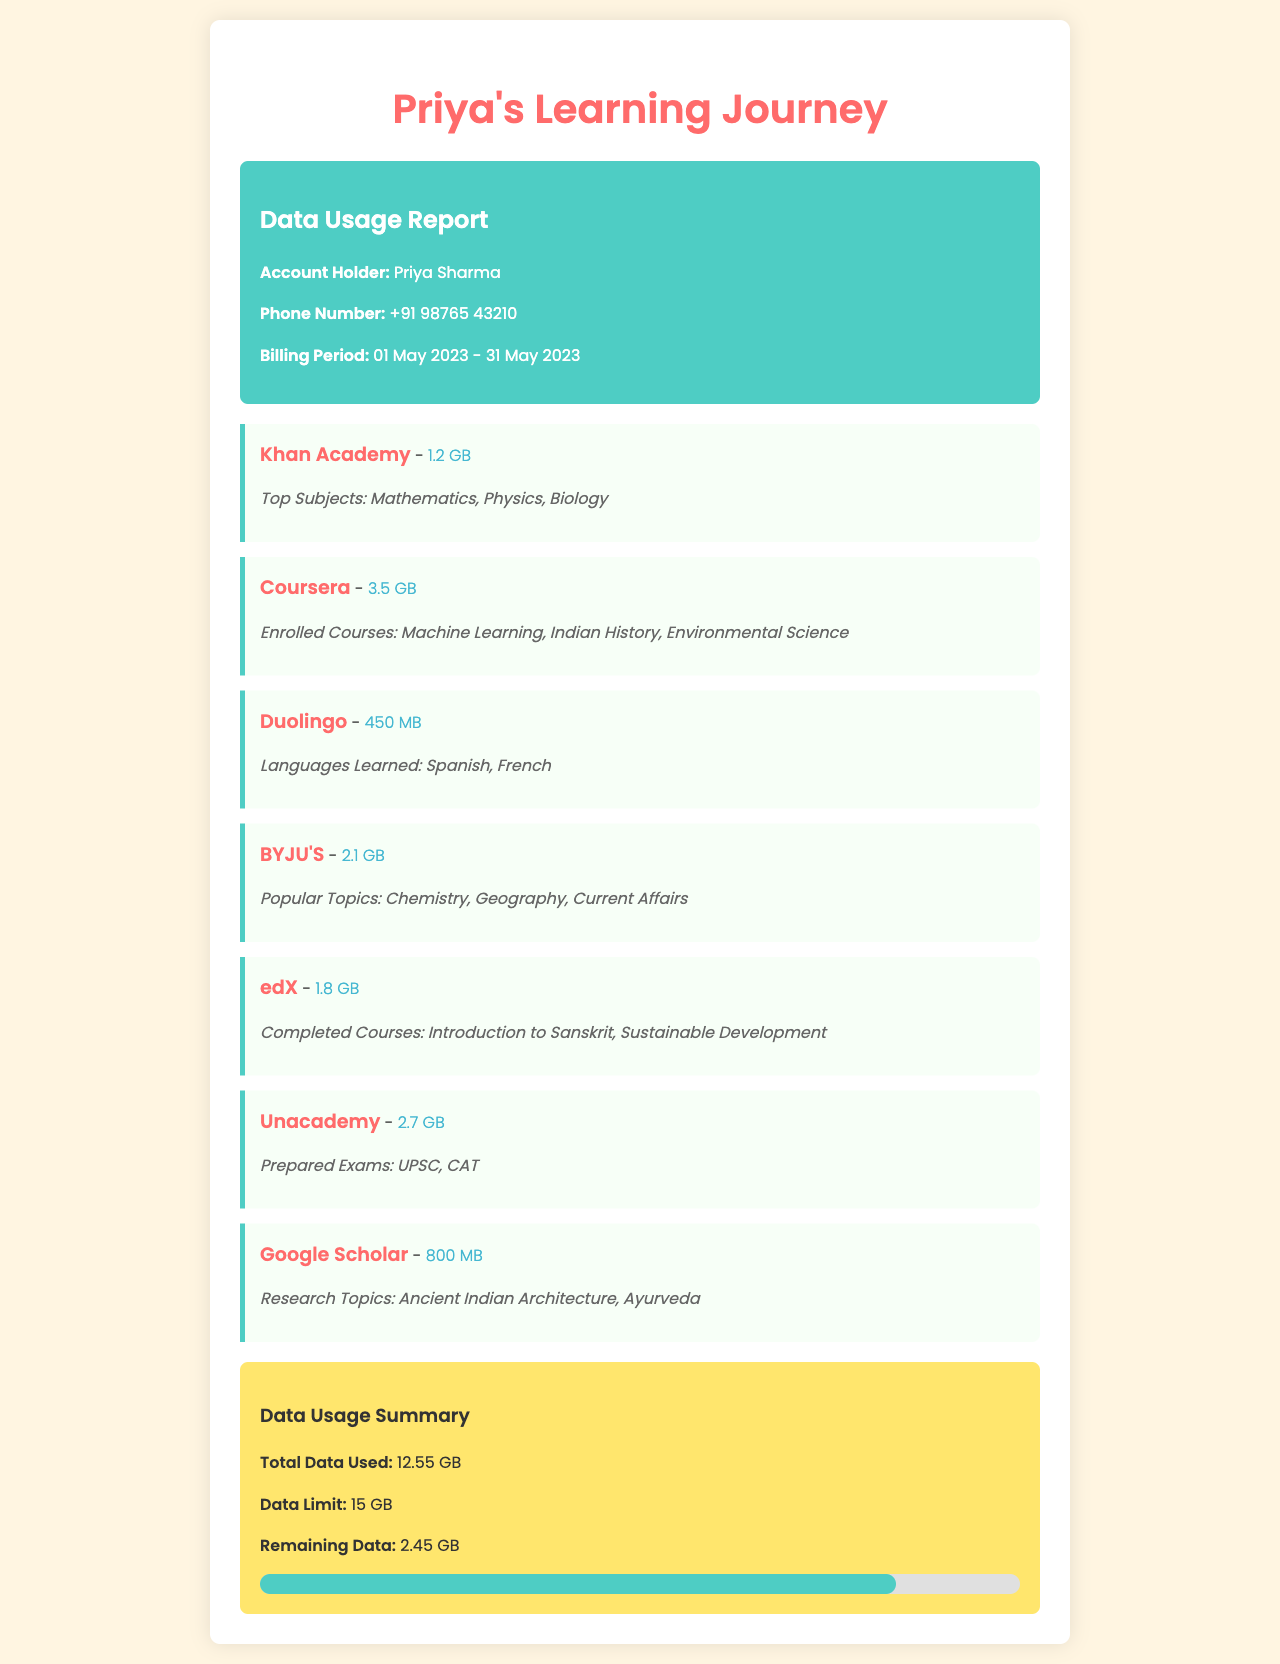What is the name of the account holder? The account holder's name is explicitly stated in the document as Priya Sharma.
Answer: Priya Sharma What is the phone number listed in the report? The document provides the phone number used by Priya as +91 98765 43210.
Answer: +91 98765 43210 What is the total data usage for the month? The total data usage is summarized at the end of the document, which totals 12.55 GB.
Answer: 12.55 GB How much data is consumed by the Coursera app? The document mentions that the Coursera app consumed 3.5 GB of data.
Answer: 3.5 GB Which subject is included in Khan Academy's usage? The document indicates that Mathematics is one of the top subjects for Khan Academy.
Answer: Mathematics What is the remaining data after the reported usage? The report states there is a remaining data of 2.45 GB following the usage during the billing period.
Answer: 2.45 GB Which app has the highest data consumption? According to the document, Coursera has the highest data consumption of 3.5 GB.
Answer: Coursera What were the languages learned using Duolingo? The document lists Spanish and French as the languages learned on Duolingo.
Answer: Spanish, French How many courses has Priya completed on edX? The document notes that Priya has completed courses on Introduction to Sanskrit and Sustainable Development, totaling 2 courses.
Answer: 2 courses 